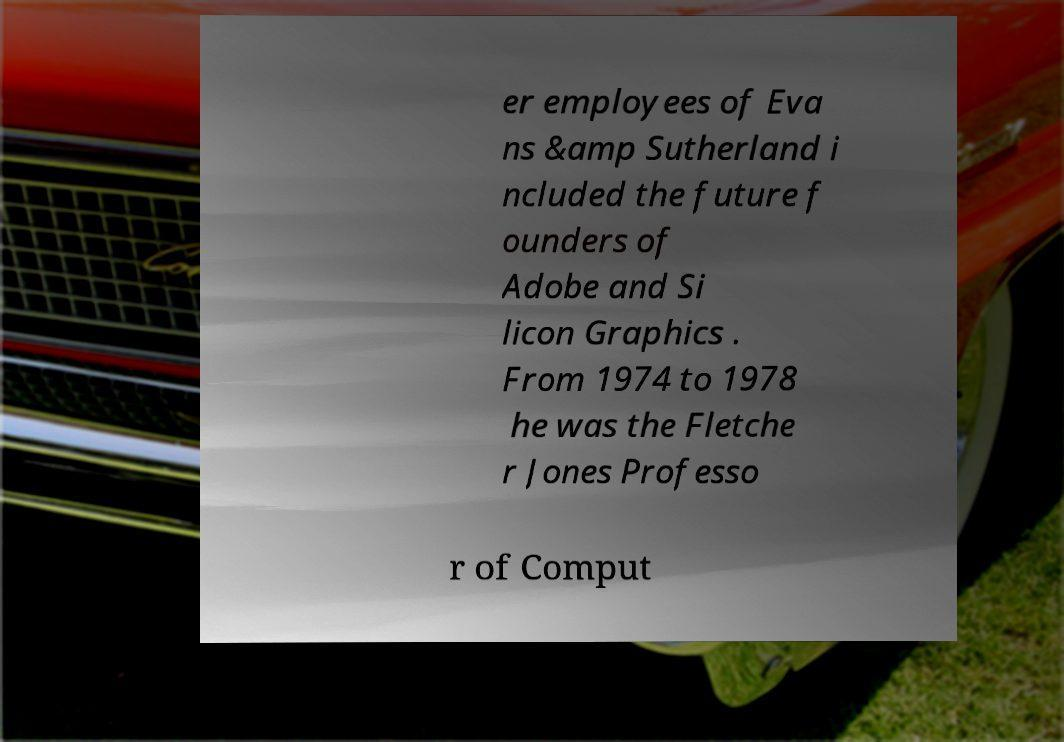Could you extract and type out the text from this image? er employees of Eva ns &amp Sutherland i ncluded the future f ounders of Adobe and Si licon Graphics . From 1974 to 1978 he was the Fletche r Jones Professo r of Comput 